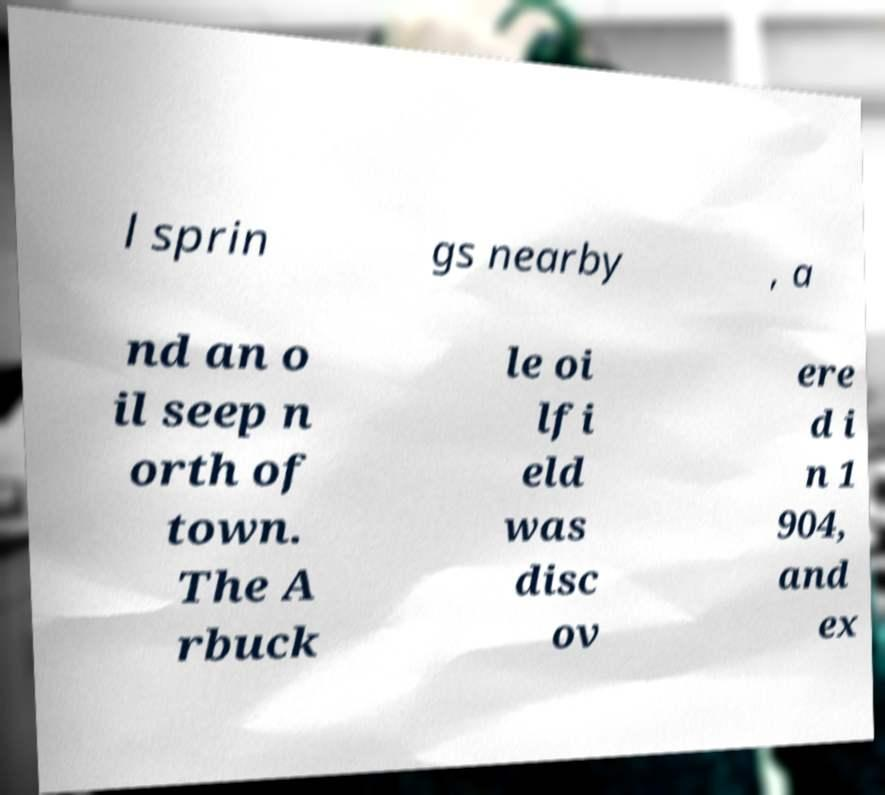What messages or text are displayed in this image? I need them in a readable, typed format. l sprin gs nearby , a nd an o il seep n orth of town. The A rbuck le oi lfi eld was disc ov ere d i n 1 904, and ex 